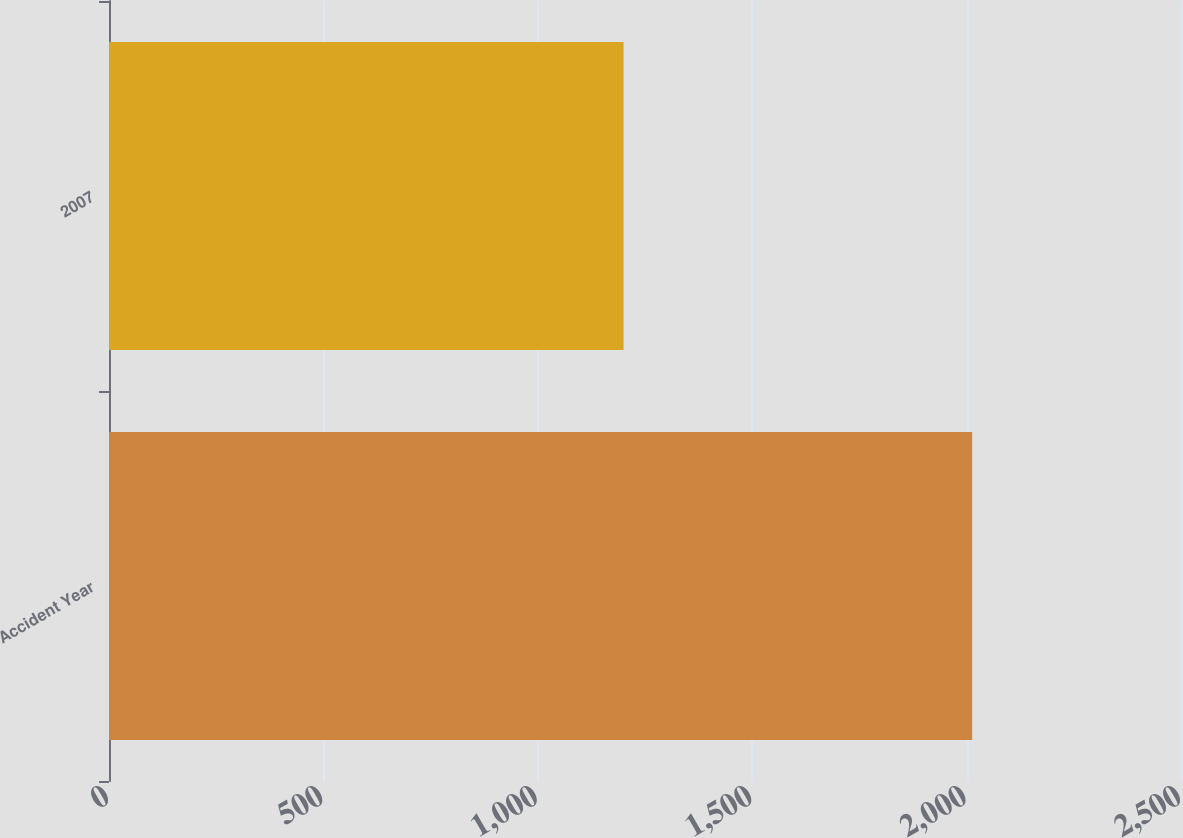Convert chart. <chart><loc_0><loc_0><loc_500><loc_500><bar_chart><fcel>Accident Year<fcel>2007<nl><fcel>2013<fcel>1200<nl></chart> 